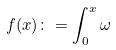Convert formula to latex. <formula><loc_0><loc_0><loc_500><loc_500>f ( x ) \colon = \int _ { 0 } ^ { x } \omega</formula> 